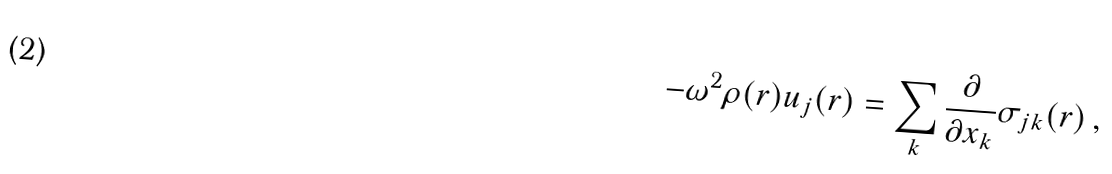Convert formula to latex. <formula><loc_0><loc_0><loc_500><loc_500>- \omega ^ { 2 } \rho ( { r } ) u _ { j } ( { r } ) = \sum _ { k } \frac { \partial } { \partial x _ { k } } \sigma _ { j k } ( { r } ) \, ,</formula> 